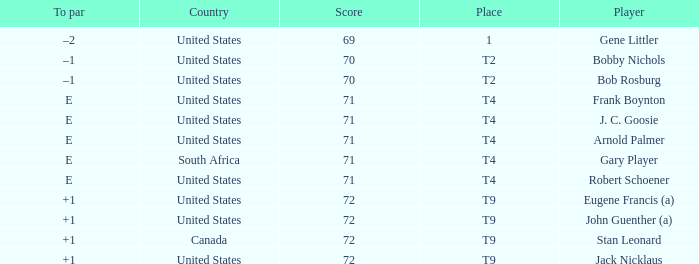Would you be able to parse every entry in this table? {'header': ['To par', 'Country', 'Score', 'Place', 'Player'], 'rows': [['–2', 'United States', '69', '1', 'Gene Littler'], ['–1', 'United States', '70', 'T2', 'Bobby Nichols'], ['–1', 'United States', '70', 'T2', 'Bob Rosburg'], ['E', 'United States', '71', 'T4', 'Frank Boynton'], ['E', 'United States', '71', 'T4', 'J. C. Goosie'], ['E', 'United States', '71', 'T4', 'Arnold Palmer'], ['E', 'South Africa', '71', 'T4', 'Gary Player'], ['E', 'United States', '71', 'T4', 'Robert Schoener'], ['+1', 'United States', '72', 'T9', 'Eugene Francis (a)'], ['+1', 'United States', '72', 'T9', 'John Guenther (a)'], ['+1', 'Canada', '72', 'T9', 'Stan Leonard'], ['+1', 'United States', '72', 'T9', 'Jack Nicklaus']]} What is Place, when Score is less than 70? 1.0. 